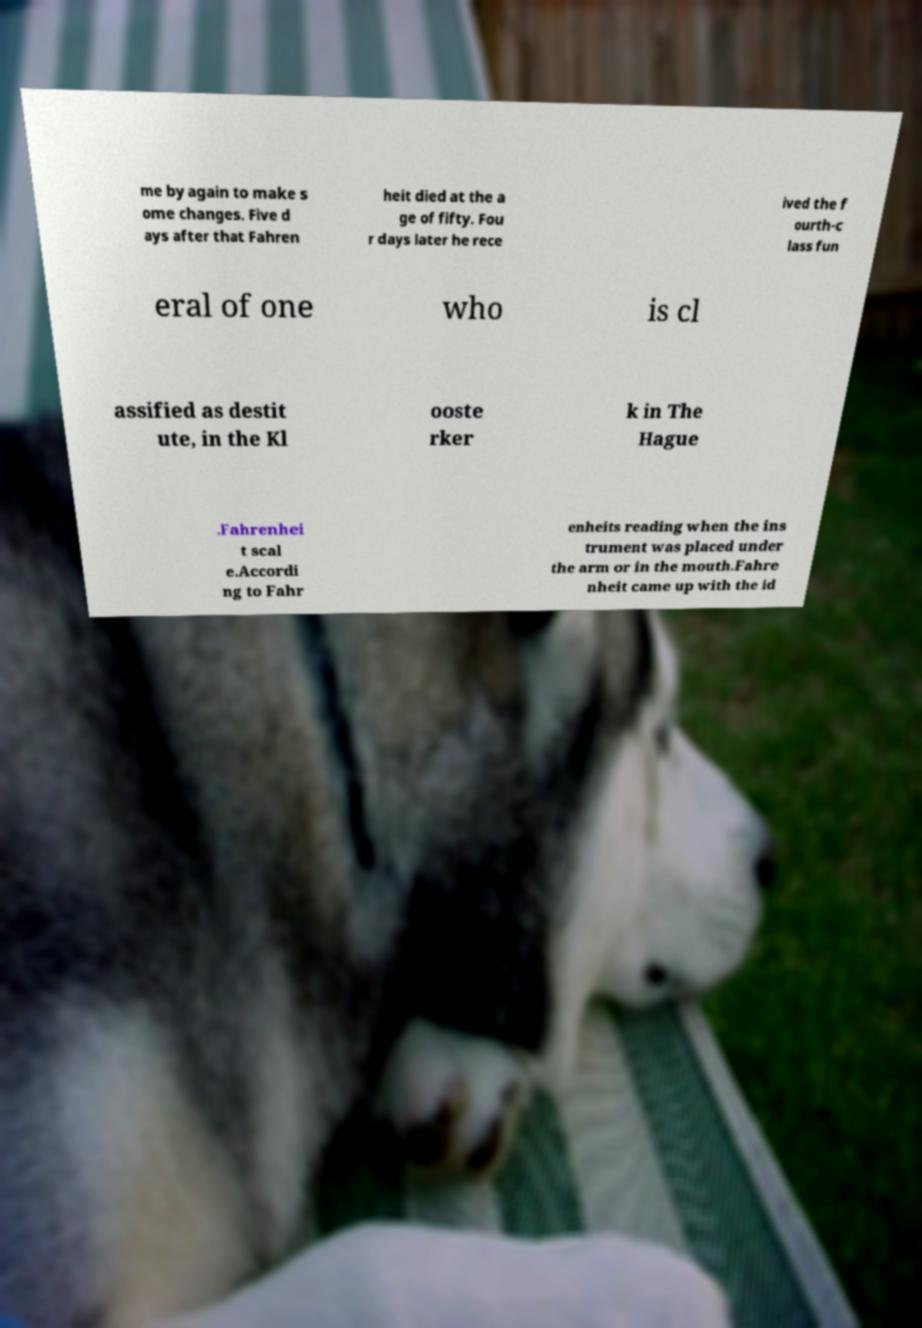Can you read and provide the text displayed in the image?This photo seems to have some interesting text. Can you extract and type it out for me? me by again to make s ome changes. Five d ays after that Fahren heit died at the a ge of fifty. Fou r days later he rece ived the f ourth-c lass fun eral of one who is cl assified as destit ute, in the Kl ooste rker k in The Hague .Fahrenhei t scal e.Accordi ng to Fahr enheits reading when the ins trument was placed under the arm or in the mouth.Fahre nheit came up with the id 